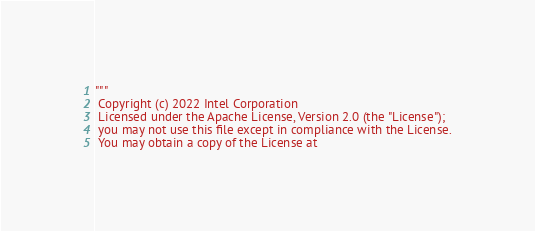<code> <loc_0><loc_0><loc_500><loc_500><_Python_>"""
 Copyright (c) 2022 Intel Corporation
 Licensed under the Apache License, Version 2.0 (the "License");
 you may not use this file except in compliance with the License.
 You may obtain a copy of the License at</code> 